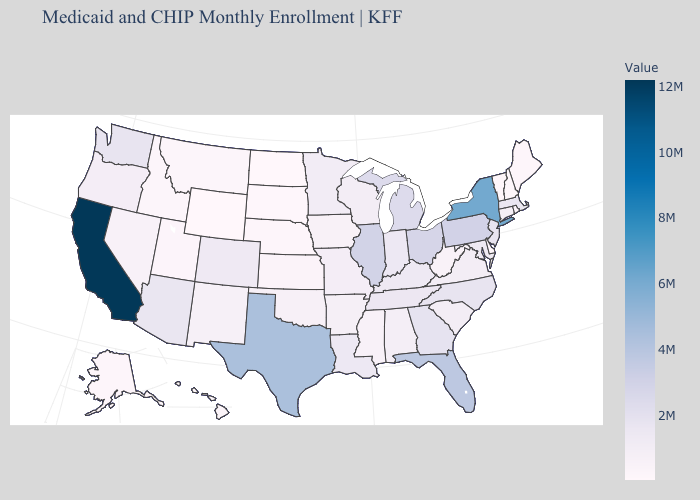Does Wyoming have the lowest value in the USA?
Give a very brief answer. Yes. Does Idaho have the lowest value in the USA?
Answer briefly. No. Which states have the lowest value in the USA?
Write a very short answer. Wyoming. Among the states that border Ohio , does Michigan have the highest value?
Concise answer only. No. Is the legend a continuous bar?
Keep it brief. Yes. Is the legend a continuous bar?
Concise answer only. Yes. 